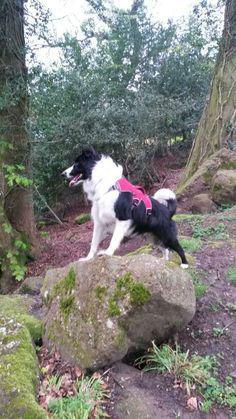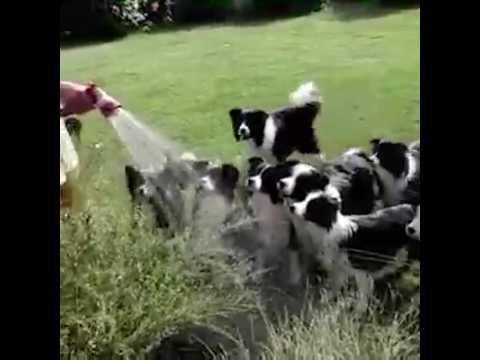The first image is the image on the left, the second image is the image on the right. Evaluate the accuracy of this statement regarding the images: "One image includes a dog running toward the camera, and the other image shows reclining dogs, with some kind of heaped plant material in a horizontal row.". Is it true? Answer yes or no. No. The first image is the image on the left, the second image is the image on the right. Evaluate the accuracy of this statement regarding the images: "There are more dogs in the image on the right.". Is it true? Answer yes or no. Yes. 